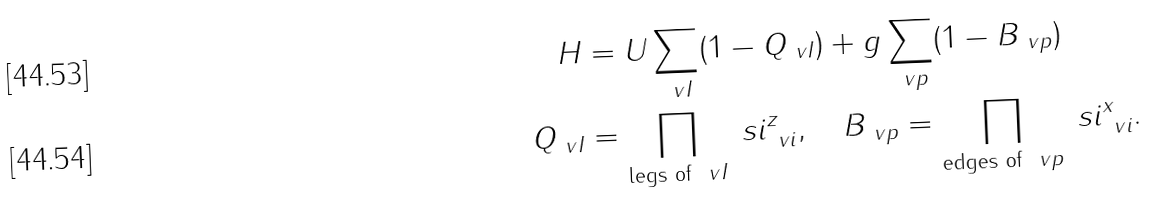Convert formula to latex. <formula><loc_0><loc_0><loc_500><loc_500>H & = U \sum _ { \ v I } ( 1 - Q _ { \ v I } ) + g \sum _ { \ v p } ( 1 - B _ { \ v p } ) \\ Q _ { \ v I } & = \prod _ { \text {legs of } \ v I } \ s i ^ { z } _ { \ v i } , \quad B _ { \ v p } = \prod _ { \text {edges of } \ v p } \ s i ^ { x } _ { \ v i } .</formula> 